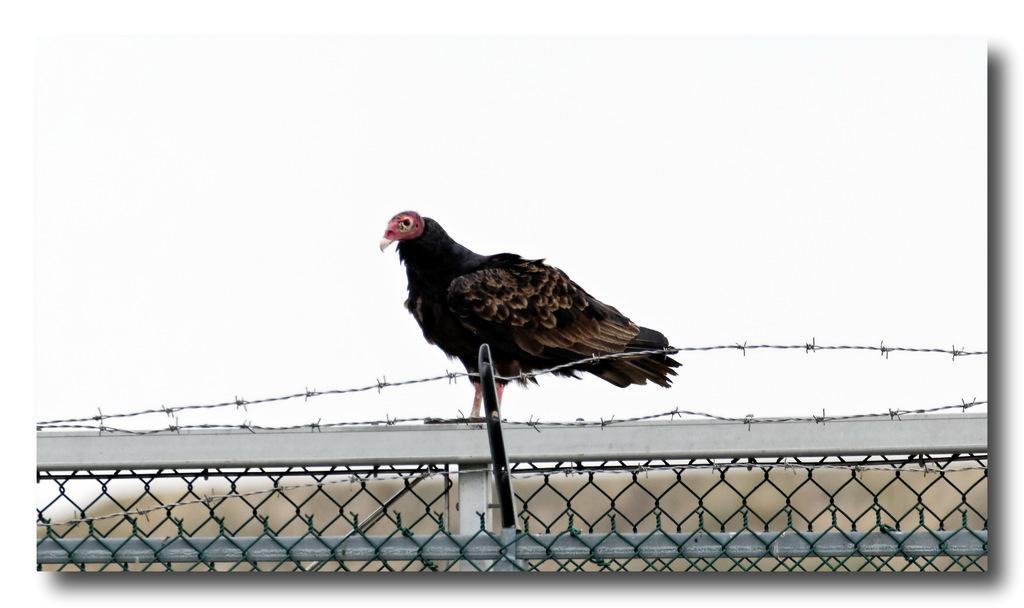How would you summarize this image in a sentence or two? In this picture we can observe a bird on the fence. This bird is in black and brown color. In the background there is a sky. 